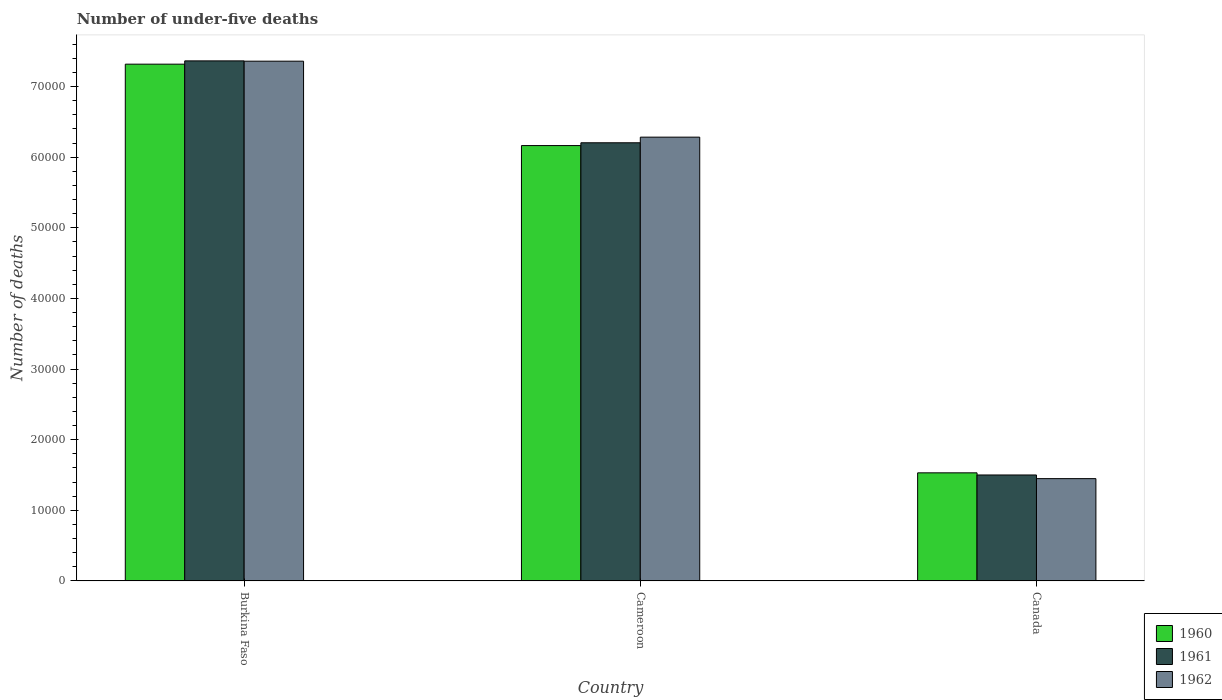How many different coloured bars are there?
Make the answer very short. 3. How many bars are there on the 1st tick from the left?
Your answer should be very brief. 3. What is the number of under-five deaths in 1962 in Burkina Faso?
Offer a terse response. 7.36e+04. Across all countries, what is the maximum number of under-five deaths in 1960?
Provide a succinct answer. 7.32e+04. Across all countries, what is the minimum number of under-five deaths in 1961?
Offer a very short reply. 1.50e+04. In which country was the number of under-five deaths in 1960 maximum?
Offer a very short reply. Burkina Faso. What is the total number of under-five deaths in 1962 in the graph?
Your answer should be very brief. 1.51e+05. What is the difference between the number of under-five deaths in 1960 in Burkina Faso and that in Cameroon?
Ensure brevity in your answer.  1.15e+04. What is the difference between the number of under-five deaths in 1962 in Burkina Faso and the number of under-five deaths in 1960 in Cameroon?
Your answer should be very brief. 1.20e+04. What is the average number of under-five deaths in 1960 per country?
Your response must be concise. 5.00e+04. What is the difference between the number of under-five deaths of/in 1962 and number of under-five deaths of/in 1961 in Canada?
Make the answer very short. -517. What is the ratio of the number of under-five deaths in 1961 in Burkina Faso to that in Cameroon?
Provide a succinct answer. 1.19. Is the number of under-five deaths in 1960 in Burkina Faso less than that in Canada?
Offer a very short reply. No. What is the difference between the highest and the second highest number of under-five deaths in 1961?
Ensure brevity in your answer.  5.86e+04. What is the difference between the highest and the lowest number of under-five deaths in 1962?
Keep it short and to the point. 5.91e+04. What does the 3rd bar from the right in Canada represents?
Give a very brief answer. 1960. How many bars are there?
Offer a very short reply. 9. Are all the bars in the graph horizontal?
Make the answer very short. No. Does the graph contain any zero values?
Give a very brief answer. No. Where does the legend appear in the graph?
Make the answer very short. Bottom right. How are the legend labels stacked?
Keep it short and to the point. Vertical. What is the title of the graph?
Make the answer very short. Number of under-five deaths. Does "1981" appear as one of the legend labels in the graph?
Provide a succinct answer. No. What is the label or title of the Y-axis?
Your answer should be compact. Number of deaths. What is the Number of deaths in 1960 in Burkina Faso?
Provide a short and direct response. 7.32e+04. What is the Number of deaths of 1961 in Burkina Faso?
Your answer should be compact. 7.36e+04. What is the Number of deaths of 1962 in Burkina Faso?
Your answer should be very brief. 7.36e+04. What is the Number of deaths in 1960 in Cameroon?
Offer a very short reply. 6.16e+04. What is the Number of deaths of 1961 in Cameroon?
Your response must be concise. 6.20e+04. What is the Number of deaths of 1962 in Cameroon?
Give a very brief answer. 6.28e+04. What is the Number of deaths in 1960 in Canada?
Ensure brevity in your answer.  1.53e+04. What is the Number of deaths in 1961 in Canada?
Keep it short and to the point. 1.50e+04. What is the Number of deaths of 1962 in Canada?
Provide a succinct answer. 1.45e+04. Across all countries, what is the maximum Number of deaths in 1960?
Provide a succinct answer. 7.32e+04. Across all countries, what is the maximum Number of deaths in 1961?
Ensure brevity in your answer.  7.36e+04. Across all countries, what is the maximum Number of deaths of 1962?
Offer a very short reply. 7.36e+04. Across all countries, what is the minimum Number of deaths in 1960?
Your response must be concise. 1.53e+04. Across all countries, what is the minimum Number of deaths in 1961?
Your answer should be compact. 1.50e+04. Across all countries, what is the minimum Number of deaths in 1962?
Your response must be concise. 1.45e+04. What is the total Number of deaths in 1960 in the graph?
Your answer should be very brief. 1.50e+05. What is the total Number of deaths in 1961 in the graph?
Ensure brevity in your answer.  1.51e+05. What is the total Number of deaths of 1962 in the graph?
Provide a succinct answer. 1.51e+05. What is the difference between the Number of deaths of 1960 in Burkina Faso and that in Cameroon?
Offer a very short reply. 1.15e+04. What is the difference between the Number of deaths of 1961 in Burkina Faso and that in Cameroon?
Your response must be concise. 1.16e+04. What is the difference between the Number of deaths of 1962 in Burkina Faso and that in Cameroon?
Make the answer very short. 1.08e+04. What is the difference between the Number of deaths in 1960 in Burkina Faso and that in Canada?
Your answer should be very brief. 5.79e+04. What is the difference between the Number of deaths in 1961 in Burkina Faso and that in Canada?
Provide a short and direct response. 5.86e+04. What is the difference between the Number of deaths of 1962 in Burkina Faso and that in Canada?
Your response must be concise. 5.91e+04. What is the difference between the Number of deaths in 1960 in Cameroon and that in Canada?
Provide a short and direct response. 4.63e+04. What is the difference between the Number of deaths of 1961 in Cameroon and that in Canada?
Ensure brevity in your answer.  4.70e+04. What is the difference between the Number of deaths of 1962 in Cameroon and that in Canada?
Offer a terse response. 4.83e+04. What is the difference between the Number of deaths of 1960 in Burkina Faso and the Number of deaths of 1961 in Cameroon?
Make the answer very short. 1.11e+04. What is the difference between the Number of deaths of 1960 in Burkina Faso and the Number of deaths of 1962 in Cameroon?
Offer a very short reply. 1.03e+04. What is the difference between the Number of deaths of 1961 in Burkina Faso and the Number of deaths of 1962 in Cameroon?
Make the answer very short. 1.08e+04. What is the difference between the Number of deaths in 1960 in Burkina Faso and the Number of deaths in 1961 in Canada?
Offer a very short reply. 5.82e+04. What is the difference between the Number of deaths of 1960 in Burkina Faso and the Number of deaths of 1962 in Canada?
Offer a very short reply. 5.87e+04. What is the difference between the Number of deaths in 1961 in Burkina Faso and the Number of deaths in 1962 in Canada?
Your response must be concise. 5.91e+04. What is the difference between the Number of deaths in 1960 in Cameroon and the Number of deaths in 1961 in Canada?
Provide a short and direct response. 4.66e+04. What is the difference between the Number of deaths of 1960 in Cameroon and the Number of deaths of 1962 in Canada?
Your answer should be very brief. 4.72e+04. What is the difference between the Number of deaths in 1961 in Cameroon and the Number of deaths in 1962 in Canada?
Your answer should be compact. 4.76e+04. What is the average Number of deaths of 1960 per country?
Provide a short and direct response. 5.00e+04. What is the average Number of deaths of 1961 per country?
Provide a short and direct response. 5.02e+04. What is the average Number of deaths in 1962 per country?
Keep it short and to the point. 5.03e+04. What is the difference between the Number of deaths of 1960 and Number of deaths of 1961 in Burkina Faso?
Make the answer very short. -465. What is the difference between the Number of deaths in 1960 and Number of deaths in 1962 in Burkina Faso?
Provide a succinct answer. -423. What is the difference between the Number of deaths of 1961 and Number of deaths of 1962 in Burkina Faso?
Your answer should be very brief. 42. What is the difference between the Number of deaths in 1960 and Number of deaths in 1961 in Cameroon?
Your answer should be compact. -396. What is the difference between the Number of deaths of 1960 and Number of deaths of 1962 in Cameroon?
Provide a short and direct response. -1194. What is the difference between the Number of deaths in 1961 and Number of deaths in 1962 in Cameroon?
Your answer should be very brief. -798. What is the difference between the Number of deaths of 1960 and Number of deaths of 1961 in Canada?
Offer a terse response. 303. What is the difference between the Number of deaths in 1960 and Number of deaths in 1962 in Canada?
Offer a terse response. 820. What is the difference between the Number of deaths in 1961 and Number of deaths in 1962 in Canada?
Offer a very short reply. 517. What is the ratio of the Number of deaths in 1960 in Burkina Faso to that in Cameroon?
Your answer should be compact. 1.19. What is the ratio of the Number of deaths in 1961 in Burkina Faso to that in Cameroon?
Provide a short and direct response. 1.19. What is the ratio of the Number of deaths of 1962 in Burkina Faso to that in Cameroon?
Offer a very short reply. 1.17. What is the ratio of the Number of deaths of 1960 in Burkina Faso to that in Canada?
Your answer should be very brief. 4.78. What is the ratio of the Number of deaths in 1961 in Burkina Faso to that in Canada?
Your answer should be very brief. 4.91. What is the ratio of the Number of deaths of 1962 in Burkina Faso to that in Canada?
Offer a terse response. 5.08. What is the ratio of the Number of deaths of 1960 in Cameroon to that in Canada?
Offer a very short reply. 4.03. What is the ratio of the Number of deaths in 1961 in Cameroon to that in Canada?
Provide a short and direct response. 4.14. What is the ratio of the Number of deaths in 1962 in Cameroon to that in Canada?
Ensure brevity in your answer.  4.34. What is the difference between the highest and the second highest Number of deaths in 1960?
Provide a succinct answer. 1.15e+04. What is the difference between the highest and the second highest Number of deaths in 1961?
Offer a very short reply. 1.16e+04. What is the difference between the highest and the second highest Number of deaths in 1962?
Your answer should be compact. 1.08e+04. What is the difference between the highest and the lowest Number of deaths in 1960?
Make the answer very short. 5.79e+04. What is the difference between the highest and the lowest Number of deaths of 1961?
Provide a short and direct response. 5.86e+04. What is the difference between the highest and the lowest Number of deaths of 1962?
Offer a very short reply. 5.91e+04. 